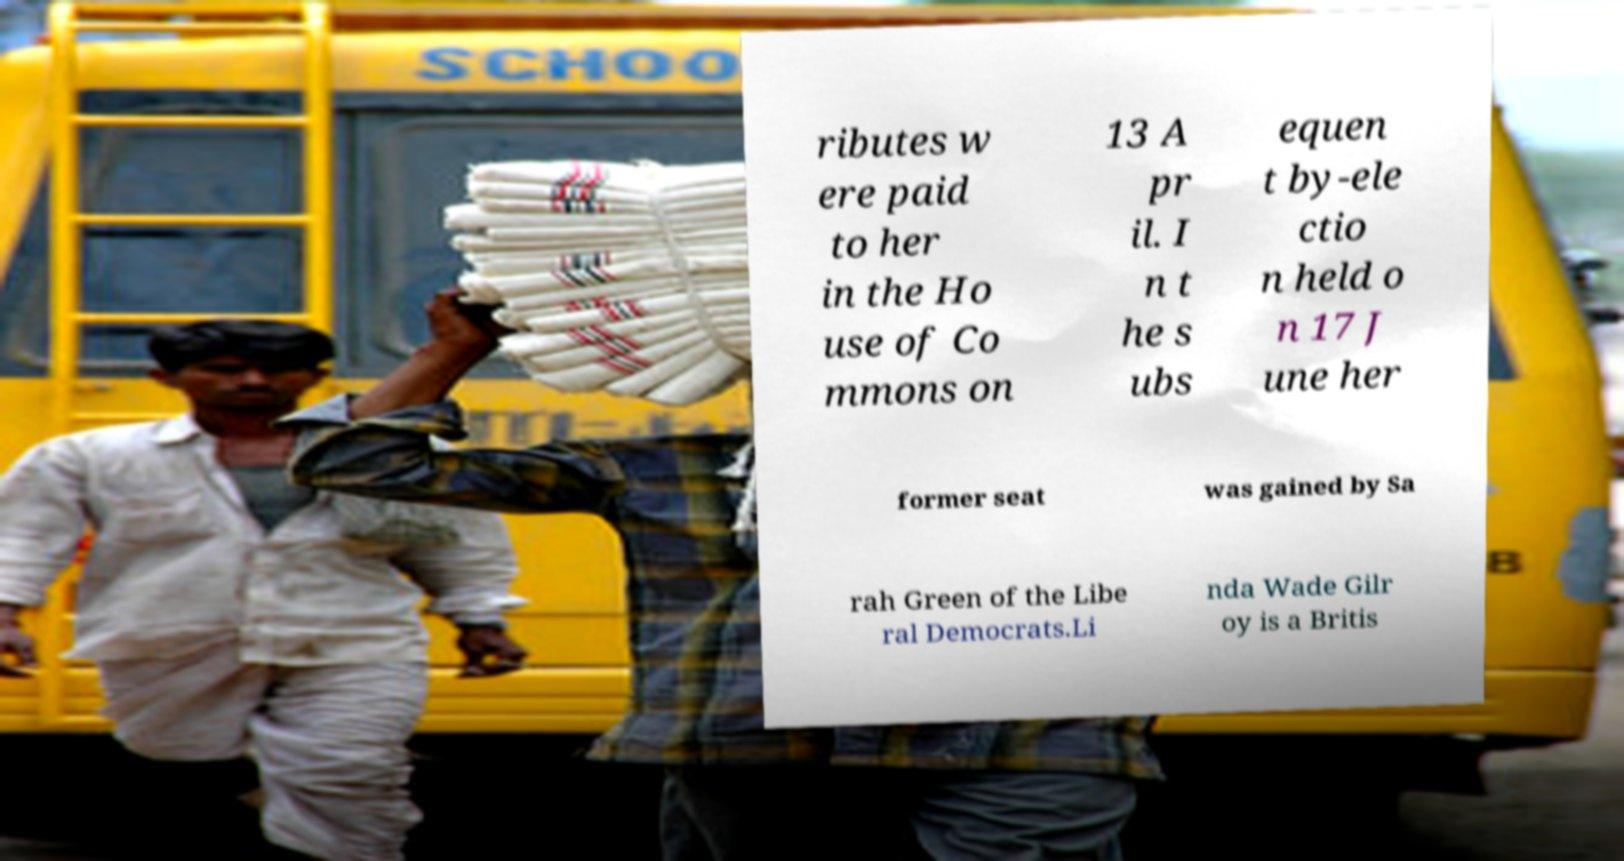What messages or text are displayed in this image? I need them in a readable, typed format. ributes w ere paid to her in the Ho use of Co mmons on 13 A pr il. I n t he s ubs equen t by-ele ctio n held o n 17 J une her former seat was gained by Sa rah Green of the Libe ral Democrats.Li nda Wade Gilr oy is a Britis 